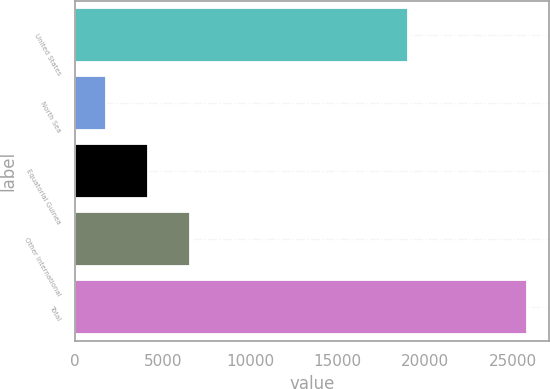<chart> <loc_0><loc_0><loc_500><loc_500><bar_chart><fcel>United States<fcel>North Sea<fcel>Equatorial Guinea<fcel>Other International<fcel>Total<nl><fcel>19019<fcel>1787<fcel>4188.8<fcel>6590.6<fcel>25805<nl></chart> 